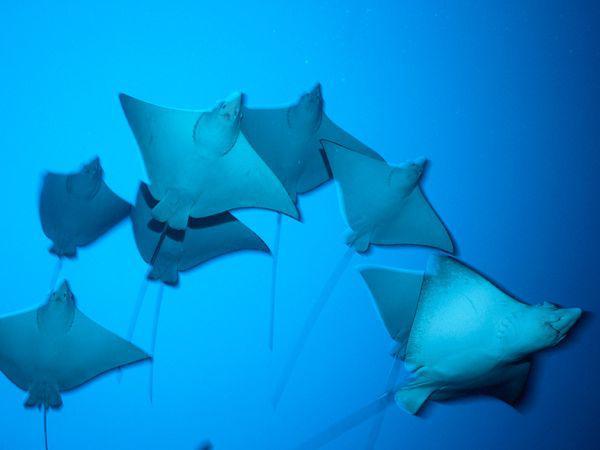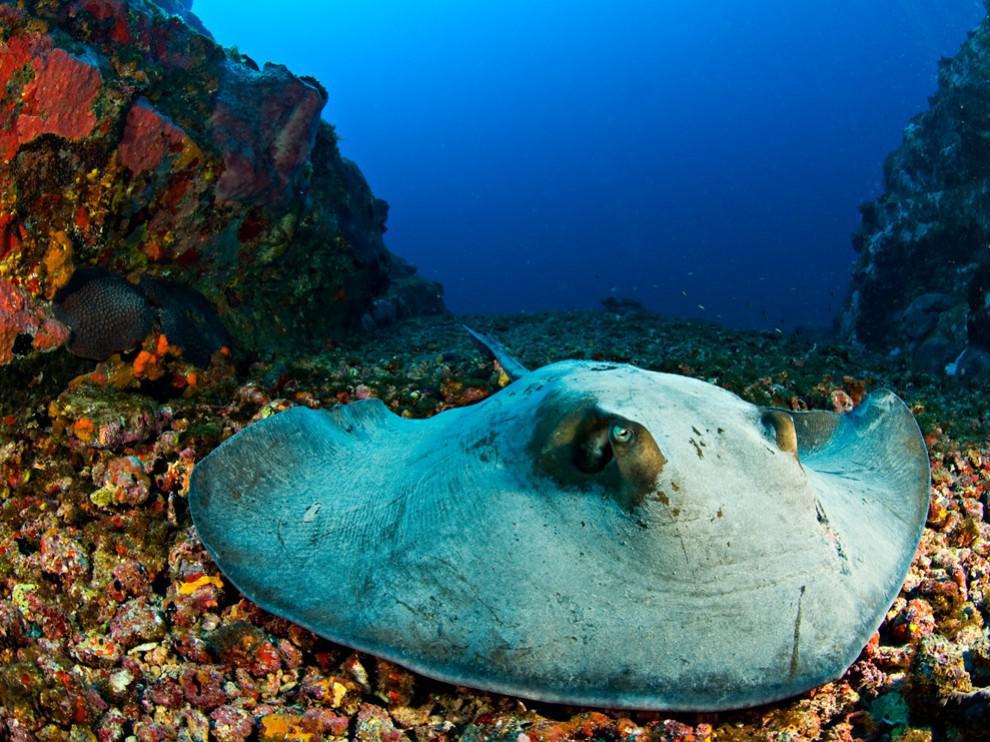The first image is the image on the left, the second image is the image on the right. Assess this claim about the two images: "An image contains no more than three stingray in the foreground.". Correct or not? Answer yes or no. Yes. The first image is the image on the left, the second image is the image on the right. For the images displayed, is the sentence "One stingray is on the ocean floor." factually correct? Answer yes or no. Yes. 